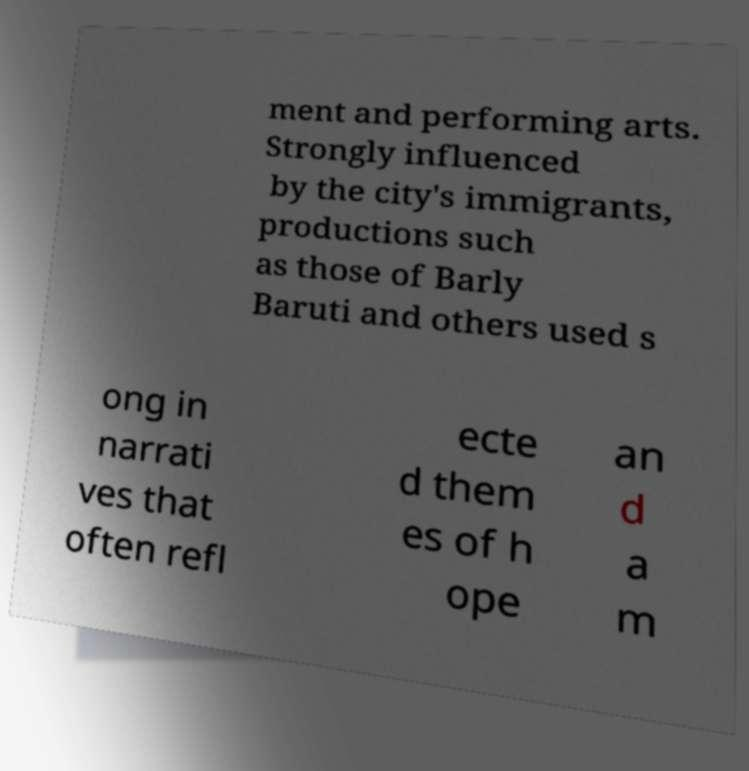Can you read and provide the text displayed in the image?This photo seems to have some interesting text. Can you extract and type it out for me? ment and performing arts. Strongly influenced by the city's immigrants, productions such as those of Barly Baruti and others used s ong in narrati ves that often refl ecte d them es of h ope an d a m 